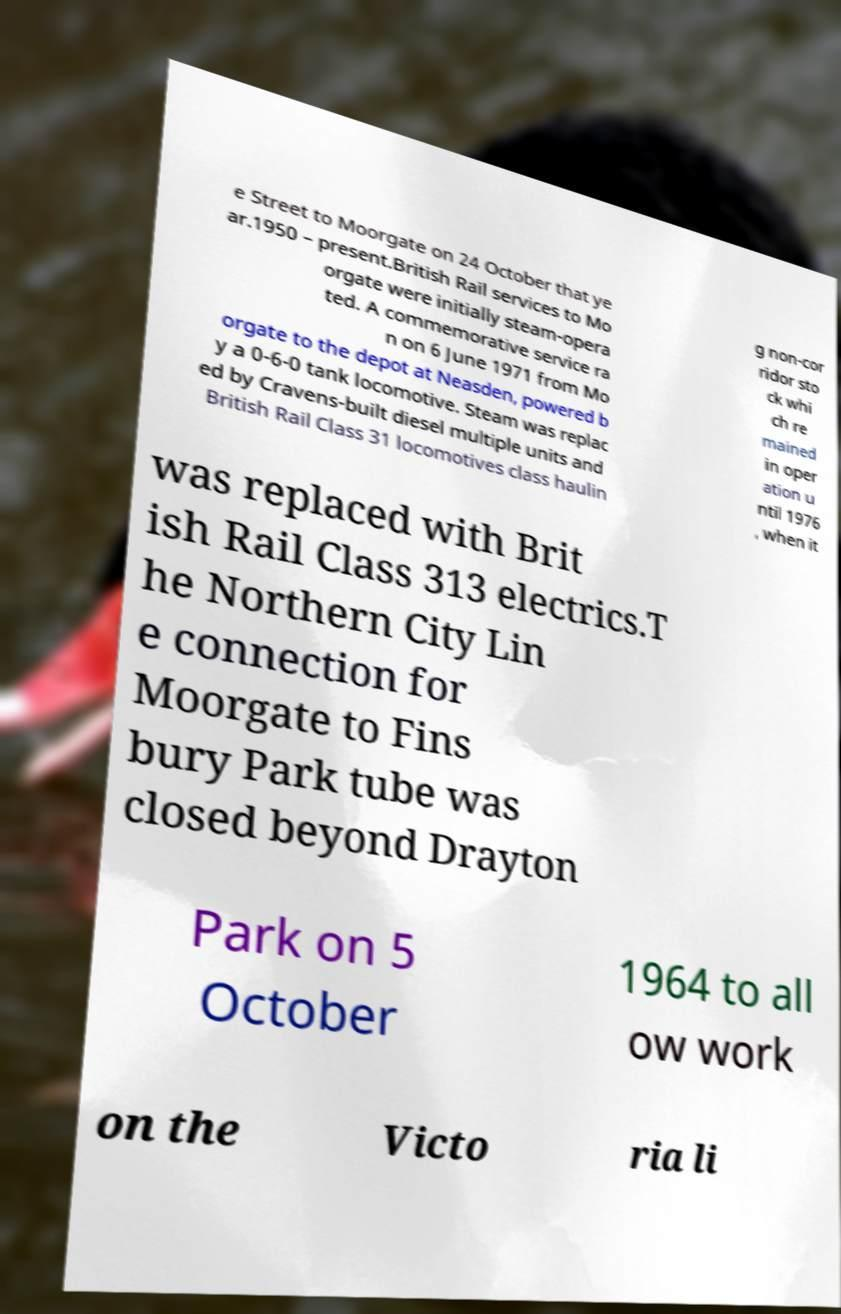Can you accurately transcribe the text from the provided image for me? e Street to Moorgate on 24 October that ye ar.1950 – present.British Rail services to Mo orgate were initially steam-opera ted. A commemorative service ra n on 6 June 1971 from Mo orgate to the depot at Neasden, powered b y a 0-6-0 tank locomotive. Steam was replac ed by Cravens-built diesel multiple units and British Rail Class 31 locomotives class haulin g non-cor ridor sto ck whi ch re mained in oper ation u ntil 1976 , when it was replaced with Brit ish Rail Class 313 electrics.T he Northern City Lin e connection for Moorgate to Fins bury Park tube was closed beyond Drayton Park on 5 October 1964 to all ow work on the Victo ria li 